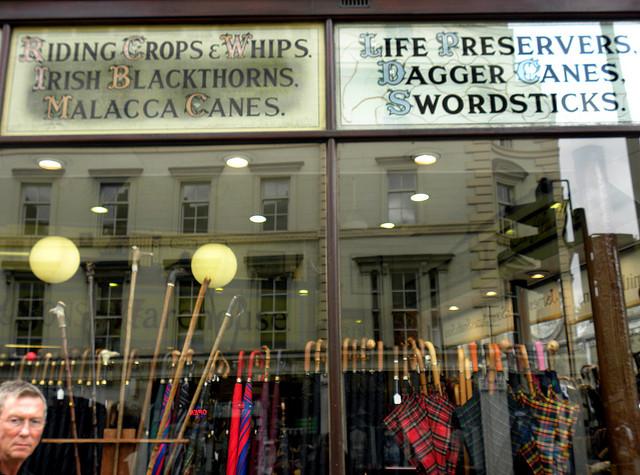What items are behind the glass window?
Be succinct. Umbrellas. How many men are shown?
Answer briefly. 1. What are the items in the photo?
Be succinct. Umbrellas. Is this photo taken at a retail location?
Give a very brief answer. Yes. 